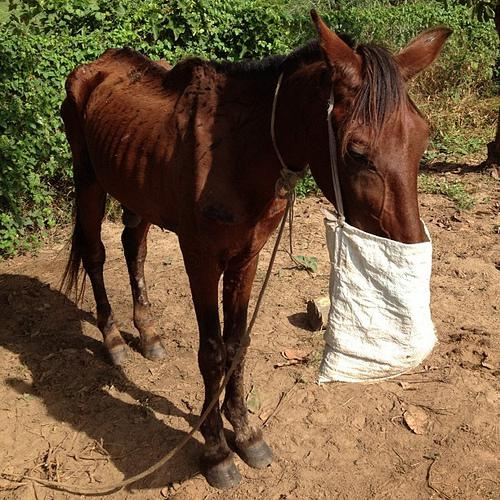Question: where is the horse?
Choices:
A. In the dirt.
B. In the barn.
C. On the grass.
D. On the street.
Answer with the letter. Answer: A Question: what is the horse doing?
Choices:
A. Sleeping.
B. Eating.
C. Walking.
D. Running.
Answer with the letter. Answer: B Question: what is around the horse's neck?
Choices:
A. The reigns.
B. A woman's arms.
C. The bridle.
D. A rope.
Answer with the letter. Answer: D 